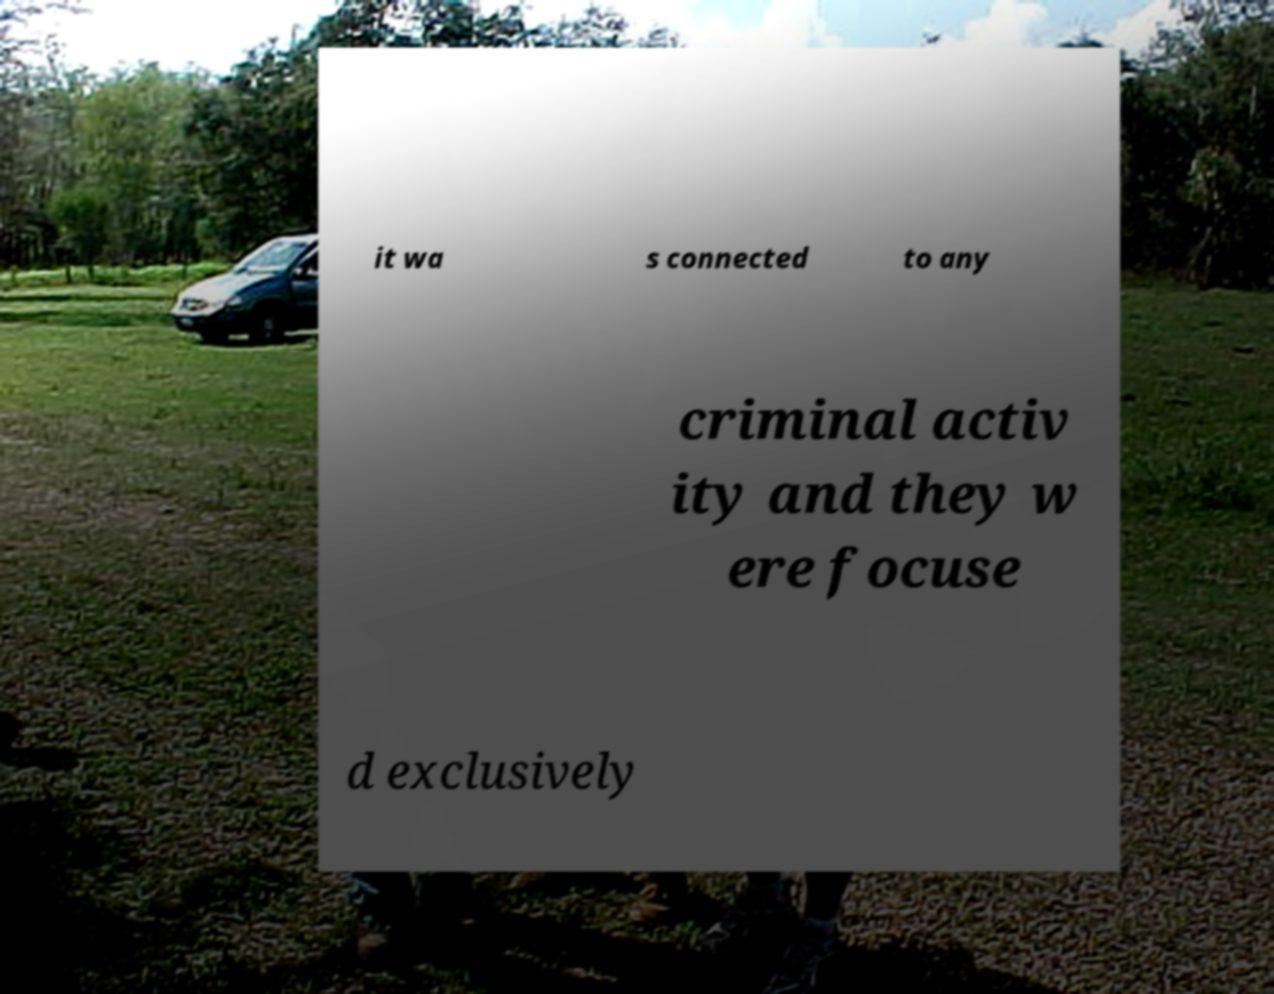What messages or text are displayed in this image? I need them in a readable, typed format. it wa s connected to any criminal activ ity and they w ere focuse d exclusively 